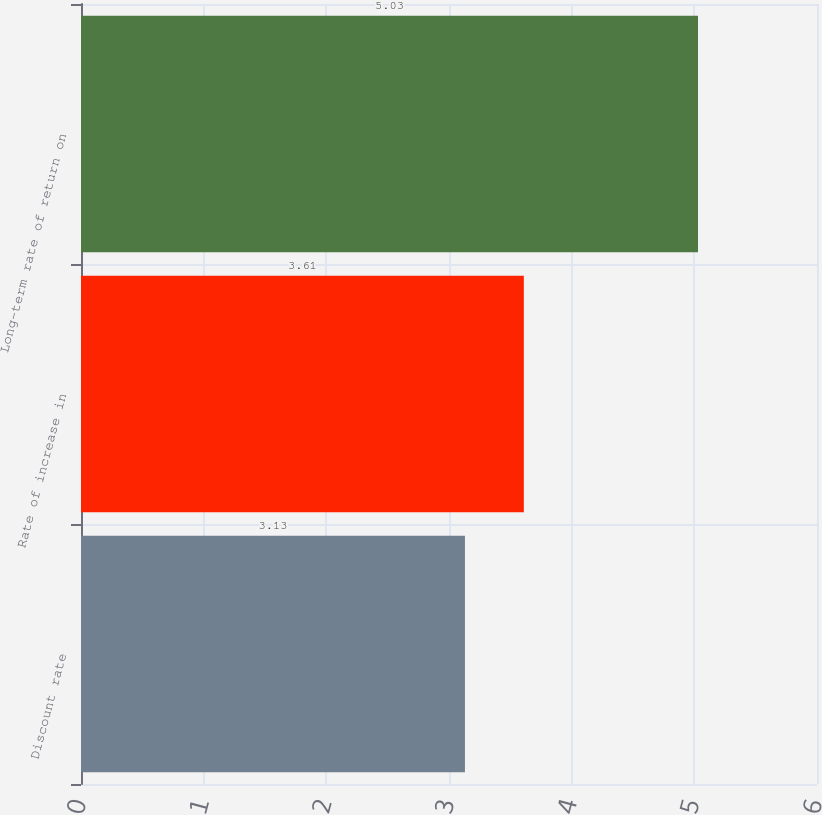Convert chart. <chart><loc_0><loc_0><loc_500><loc_500><bar_chart><fcel>Discount rate<fcel>Rate of increase in<fcel>Long-term rate of return on<nl><fcel>3.13<fcel>3.61<fcel>5.03<nl></chart> 